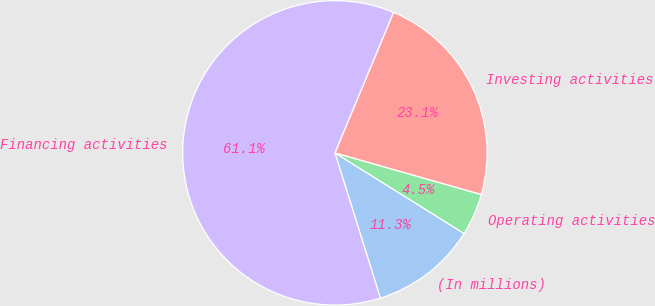Convert chart to OTSL. <chart><loc_0><loc_0><loc_500><loc_500><pie_chart><fcel>(In millions)<fcel>Operating activities<fcel>Investing activities<fcel>Financing activities<nl><fcel>11.29%<fcel>4.47%<fcel>23.12%<fcel>61.12%<nl></chart> 